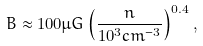Convert formula to latex. <formula><loc_0><loc_0><loc_500><loc_500>B \approx 1 0 0 \mu G \left ( \frac { n } { 1 0 ^ { 3 } c m ^ { - 3 } } \right ) ^ { 0 . 4 } ,</formula> 